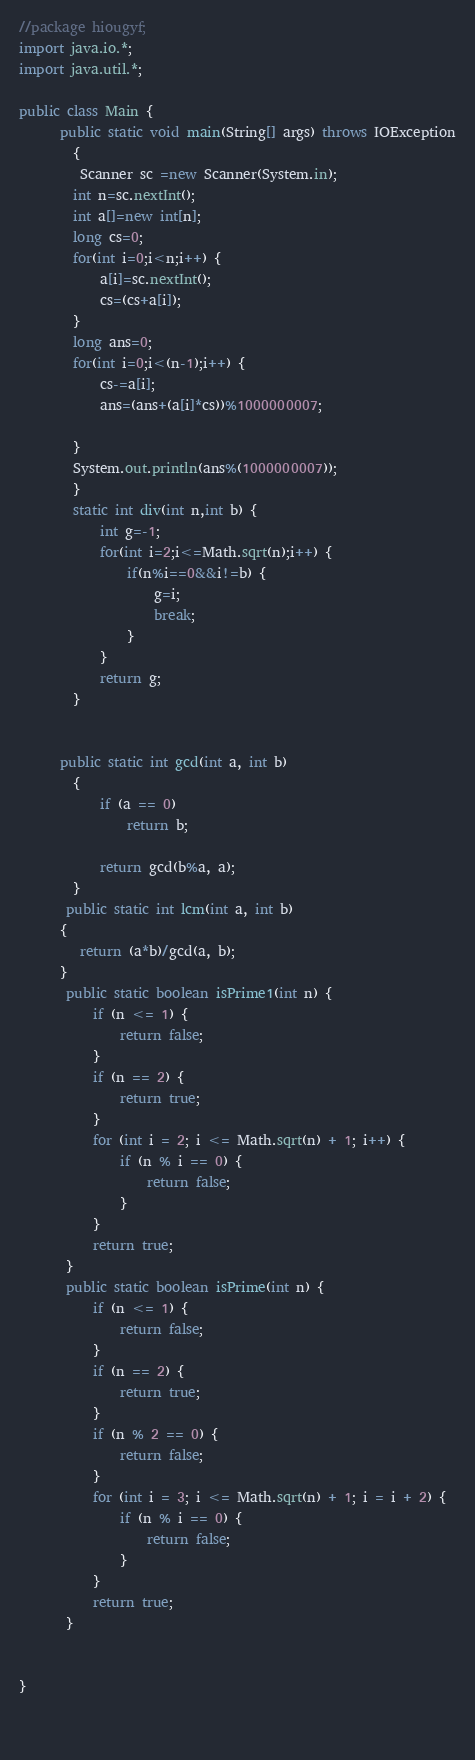Convert code to text. <code><loc_0><loc_0><loc_500><loc_500><_Java_>//package hiougyf;
import java.io.*;
import java.util.*;

public class Main {
	  public static void main(String[] args) throws IOException
	    {
		 Scanner sc =new Scanner(System.in);
		int n=sc.nextInt();
		int a[]=new int[n];
		long cs=0;
		for(int i=0;i<n;i++) {
			a[i]=sc.nextInt();
			cs=(cs+a[i]);
		}
		long ans=0;
		for(int i=0;i<(n-1);i++) {
			cs-=a[i];
			ans=(ans+(a[i]*cs))%1000000007;
			
		}
		System.out.println(ans%(1000000007));
	    }
		static int div(int n,int b) {
			int g=-1;
			for(int i=2;i<=Math.sqrt(n);i++) {
				if(n%i==0&&i!=b) {
					g=i;
					break;
				}
			}
			return g;
		}
	    
	  
	  public static int gcd(int a, int b) 
	    { 
	        if (a == 0) 
	            return b; 
	          
	        return gcd(b%a, a); 
	    } 
	   public static int lcm(int a, int b)  
	  {  
	     return (a*b)/gcd(a, b);  
	  }  
	   public static boolean isPrime1(int n) {
           if (n <= 1) {
               return false;
           }
           if (n == 2) {
               return true;
           }
           for (int i = 2; i <= Math.sqrt(n) + 1; i++) {
               if (n % i == 0) {
                   return false;
               }
           }
           return true;
       }
       public static boolean isPrime(int n) {
           if (n <= 1) {
               return false;
           }
           if (n == 2) {
               return true;
           }
           if (n % 2 == 0) {
               return false;
           }
           for (int i = 3; i <= Math.sqrt(n) + 1; i = i + 2) {
               if (n % i == 0) {
                   return false;
               }
           }
           return true;
       }
	      
	
}

  
</code> 